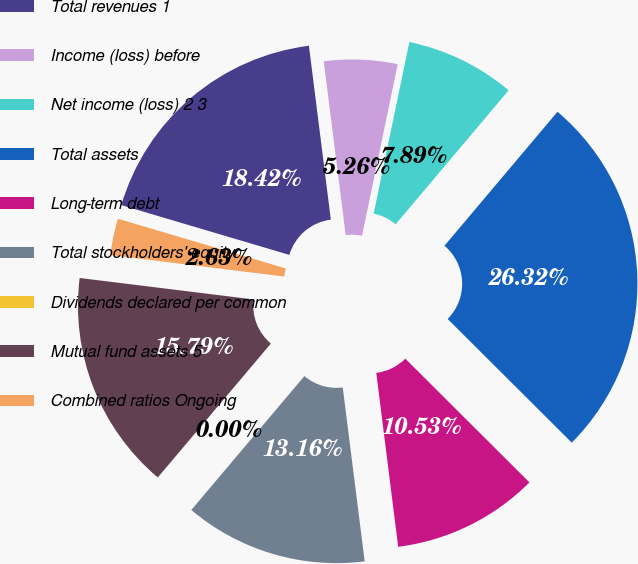Convert chart. <chart><loc_0><loc_0><loc_500><loc_500><pie_chart><fcel>Total revenues 1<fcel>Income (loss) before<fcel>Net income (loss) 2 3<fcel>Total assets<fcel>Long-term debt<fcel>Total stockholders' equity<fcel>Dividends declared per common<fcel>Mutual fund assets 5<fcel>Combined ratios Ongoing<nl><fcel>18.42%<fcel>5.26%<fcel>7.89%<fcel>26.32%<fcel>10.53%<fcel>13.16%<fcel>0.0%<fcel>15.79%<fcel>2.63%<nl></chart> 